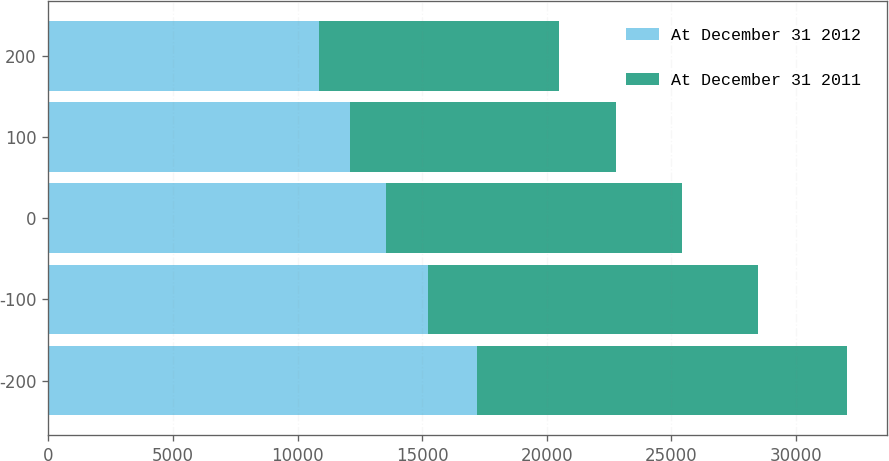Convert chart to OTSL. <chart><loc_0><loc_0><loc_500><loc_500><stacked_bar_chart><ecel><fcel>-200<fcel>-100<fcel>0<fcel>100<fcel>200<nl><fcel>At December 31 2012<fcel>17216<fcel>15231<fcel>13541<fcel>12094<fcel>10846<nl><fcel>At December 31 2011<fcel>14847<fcel>13261<fcel>11888<fcel>10694<fcel>9650<nl></chart> 